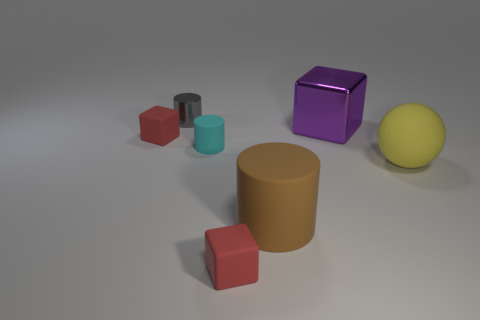There is a shiny object to the left of the purple object; does it have the same size as the big purple cube?
Your answer should be compact. No. The metal cylinder is what color?
Ensure brevity in your answer.  Gray. What is the color of the cylinder that is behind the tiny block that is left of the gray shiny cylinder?
Ensure brevity in your answer.  Gray. Are there any brown blocks made of the same material as the brown thing?
Make the answer very short. No. What is the material of the cylinder that is on the right side of the small red object in front of the large yellow matte thing?
Give a very brief answer. Rubber. How many other cyan rubber objects have the same shape as the cyan object?
Your response must be concise. 0. The tiny cyan rubber object is what shape?
Make the answer very short. Cylinder. Is the number of small gray shiny objects less than the number of small blue shiny balls?
Provide a short and direct response. No. There is a gray object that is the same shape as the brown thing; what is it made of?
Your answer should be compact. Metal. Is the number of blocks greater than the number of small cyan cylinders?
Ensure brevity in your answer.  Yes. 